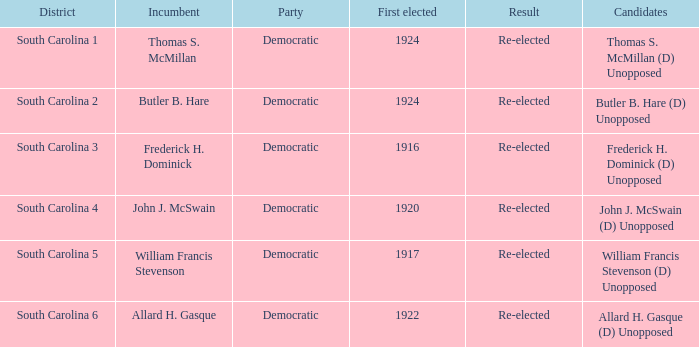Name the candidate for south carolina 1? Thomas S. McMillan (D) Unopposed. 